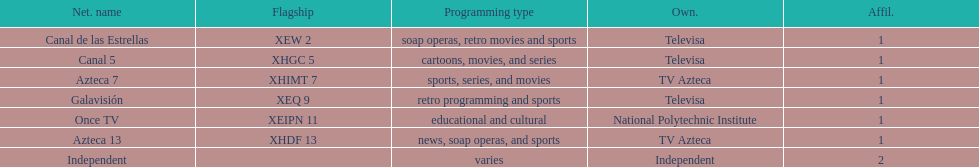Would you be able to parse every entry in this table? {'header': ['Net. name', 'Flagship', 'Programming type', 'Own.', 'Affil.'], 'rows': [['Canal de las Estrellas', 'XEW 2', 'soap operas, retro movies and sports', 'Televisa', '1'], ['Canal 5', 'XHGC 5', 'cartoons, movies, and series', 'Televisa', '1'], ['Azteca 7', 'XHIMT 7', 'sports, series, and movies', 'TV Azteca', '1'], ['Galavisión', 'XEQ 9', 'retro programming and sports', 'Televisa', '1'], ['Once TV', 'XEIPN 11', 'educational and cultural', 'National Polytechnic Institute', '1'], ['Azteca 13', 'XHDF 13', 'news, soap operas, and sports', 'TV Azteca', '1'], ['Independent', '', 'varies', 'Independent', '2']]} Who is the only network owner listed in a consecutive order in the chart? Televisa. 